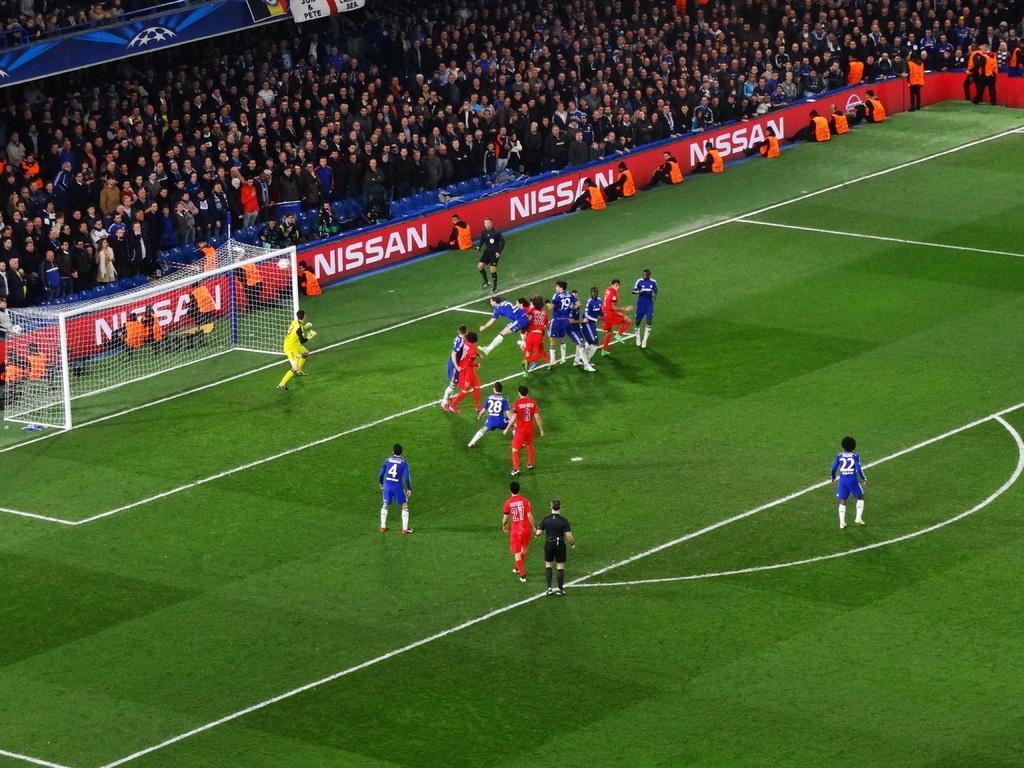Can you describe this image briefly? In the picture I can see group of people among them some are playing on the ground and some are standing in the background. I can also see a net, fence, white lines on the ground and some other objects on the ground. 